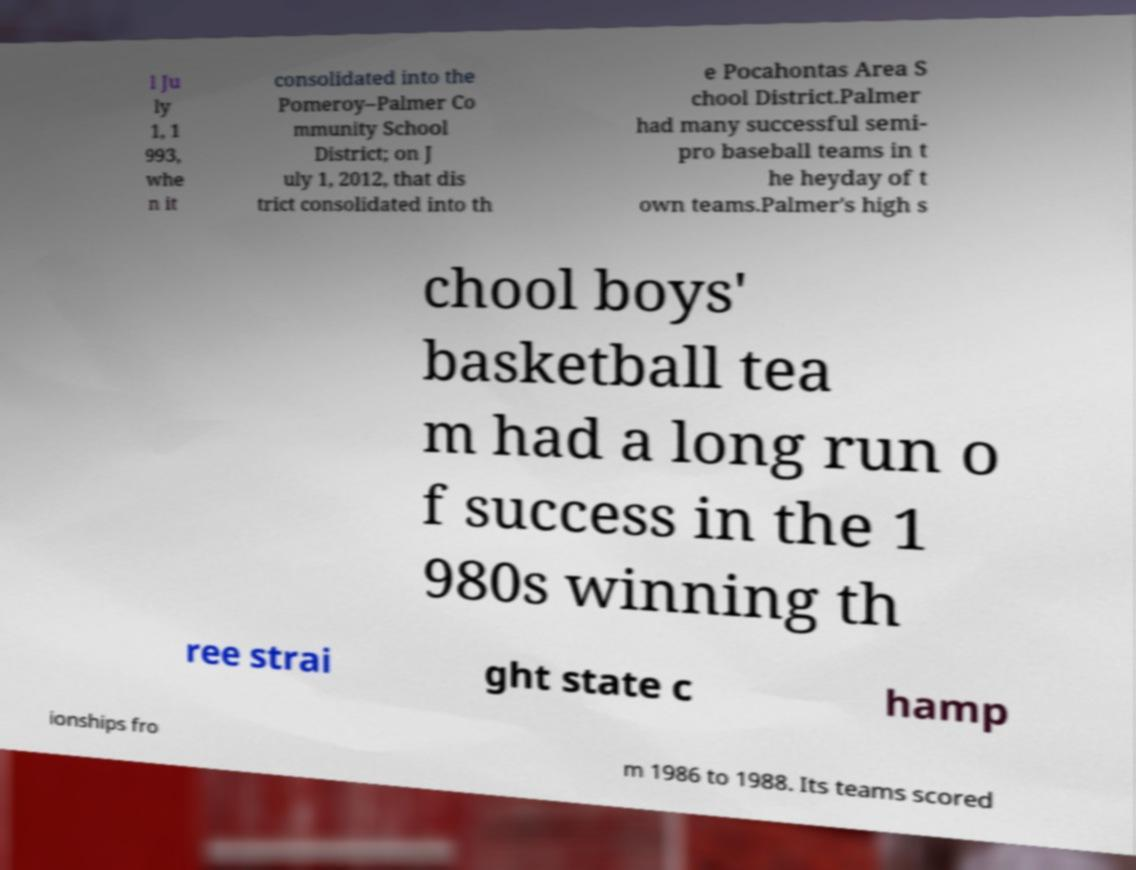There's text embedded in this image that I need extracted. Can you transcribe it verbatim? l Ju ly 1, 1 993, whe n it consolidated into the Pomeroy–Palmer Co mmunity School District; on J uly 1, 2012, that dis trict consolidated into th e Pocahontas Area S chool District.Palmer had many successful semi- pro baseball teams in t he heyday of t own teams.Palmer's high s chool boys' basketball tea m had a long run o f success in the 1 980s winning th ree strai ght state c hamp ionships fro m 1986 to 1988. Its teams scored 